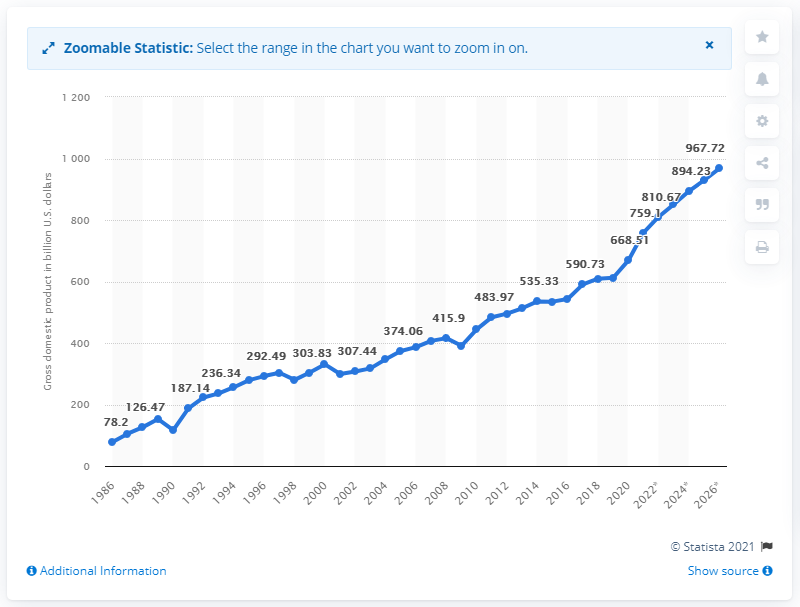What does the sudden rise in GDP around 1990 indicate? The sharp increase in Taiwan's GDP around 1990 likely indicates significant economic reforms or external investments. This era was marked by industrialization and expansion in technology and manufacturing sectors, driving higher economic productivity. Can you identify any major global events that might have affected this growth? The early 1990s were influenced by the globalization of markets and the tech boom. Additionally, Taiwan's inclusion in major global supply chains significantly boosted its economic output during this period. Global events like the easing of trade restrictions also played a role. 